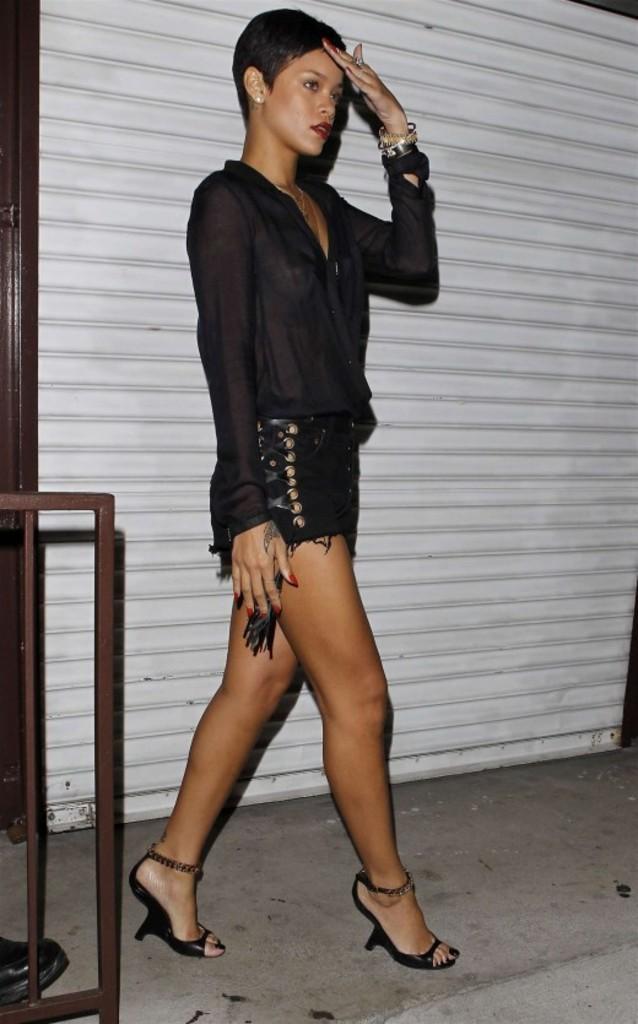Describe this image in one or two sentences. In the center of the image a lady is standing. In the background of the image rolling shutter is there. On the left side of the image rod is there. At the bottom left corner shoe is there. At the bottom of the image floor is there. 